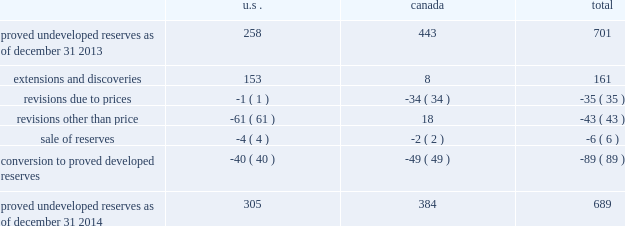Devon energy corporation and subsidiaries notes to consolidated financial statements 2013 ( continued ) proved undeveloped reserves the table presents the changes in devon 2019s total proved undeveloped reserves during 2014 ( in mmboe ) . .
At december 31 , 2014 , devon had 689 mmboe of proved undeveloped reserves .
This represents a 2 percent decrease as compared to 2013 and represents 25 percent of total proved reserves .
Drilling and development activities increased devon 2019s proved undeveloped reserves 161 mmboe and resulted in the conversion of 89 mmboe , or 13 percent , of the 2013 proved undeveloped reserves to proved developed reserves .
Costs incurred related to the development and conversion of devon 2019s proved undeveloped reserves were approximately $ 1.0 billion for 2014 .
Additionally , revisions other than price decreased devon 2019s proved undeveloped reserves 43 mmboe primarily due to evaluations of certain u.s .
Onshore dry-gas areas , which devon does not expect to develop in the next five years .
The largest revisions , which were approximately 69 mmboe , relate to the dry-gas areas in the barnett shale in north texas .
A significant amount of devon 2019s proved undeveloped reserves at the end of 2014 related to its jackfish operations .
At december 31 , 2014 and 2013 , devon 2019s jackfish proved undeveloped reserves were 384 mmboe and 441 mmboe , respectively .
Development schedules for the jackfish reserves are primarily controlled by the need to keep the processing plants at their 35000 barrel daily facility capacity .
Processing plant capacity is controlled by factors such as total steam processing capacity and steam-oil ratios .
Furthermore , development of these projects involves the up-front construction of steam injection/distribution and bitumen processing facilities .
Due to the large up-front capital investments and large reserves required to provide economic returns , the project conditions meet the specific circumstances requiring a period greater than 5 years for conversion to developed reserves .
As a result , these reserves are classified as proved undeveloped for more than five years .
Currently , the development schedule for these reserves extends though the year 2031 .
Price revisions 2014 2013 reserves increased 9 mmboe primarily due to higher gas prices in the barnett shale and the anadarko basin , partially offset by higher bitumen prices , which result in lower after-royalty volumes , in canada .
2013 2013 reserves increased 94 mmboe primarily due to higher gas prices .
Of this increase , 43 mmboe related to the barnett shale and 19 mmboe related to the rocky mountain area .
2012 2013 reserves decreased 171 mmboe primarily due to lower gas prices .
Of this decrease , 100 mmboe related to the barnett shale and 25 mmboe related to the rocky mountain area. .
What percentage of total proved undeveloped resources as of dec 31 , 2014 does extensions and discoveries and proved undeveloped resources as of dec 31 , 2013 account for? 
Computations: (((701 + 161) / 689) * 100)
Answer: 125.10885. 